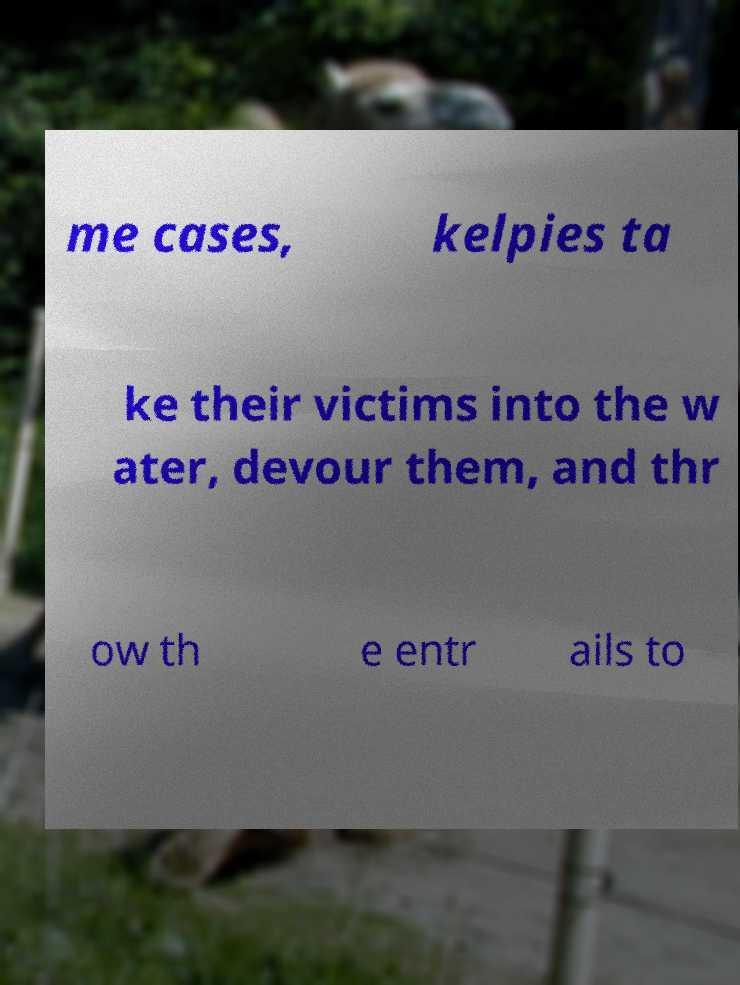What messages or text are displayed in this image? I need them in a readable, typed format. me cases, kelpies ta ke their victims into the w ater, devour them, and thr ow th e entr ails to 